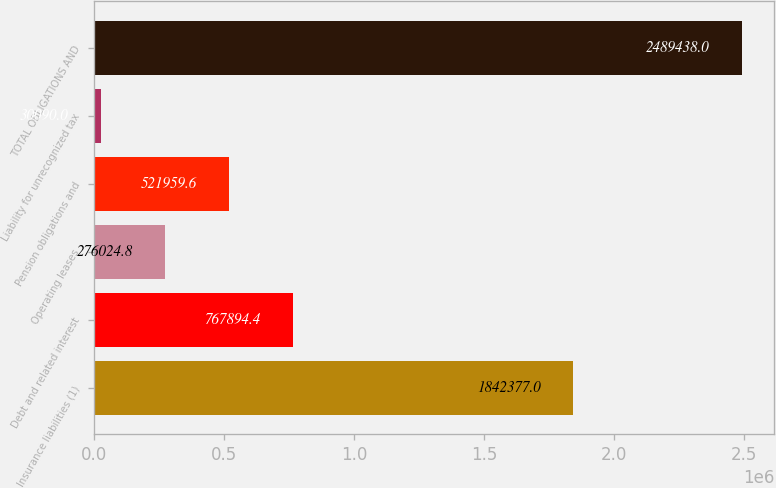<chart> <loc_0><loc_0><loc_500><loc_500><bar_chart><fcel>Insurance liabilities (1)<fcel>Debt and related interest<fcel>Operating leases<fcel>Pension obligations and<fcel>Liability for unrecognized tax<fcel>TOTAL OBLIGATIONS AND<nl><fcel>1.84238e+06<fcel>767894<fcel>276025<fcel>521960<fcel>30090<fcel>2.48944e+06<nl></chart> 